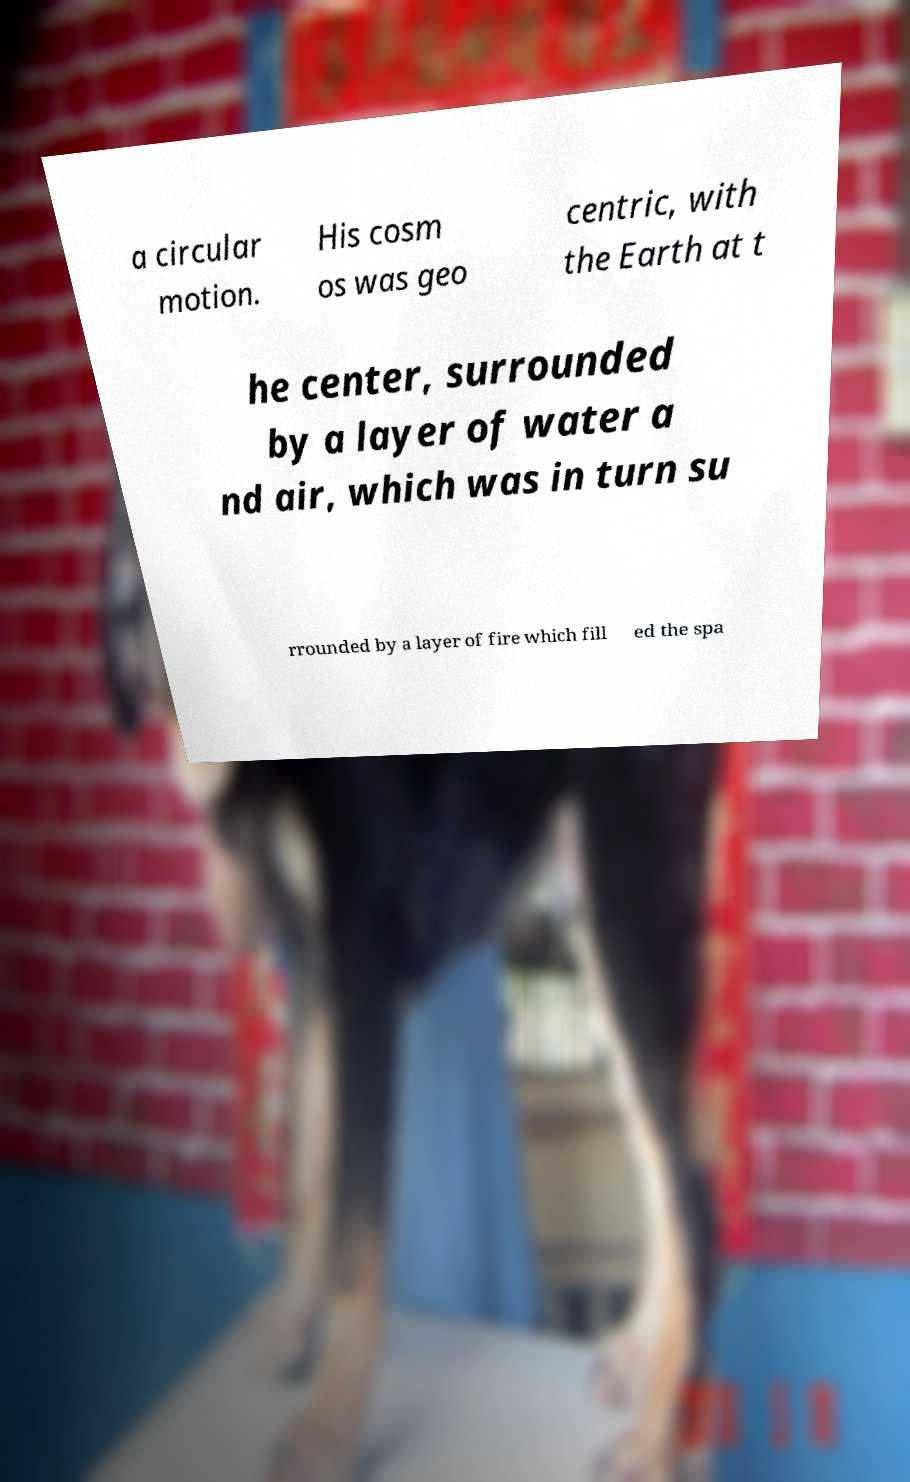There's text embedded in this image that I need extracted. Can you transcribe it verbatim? a circular motion. His cosm os was geo centric, with the Earth at t he center, surrounded by a layer of water a nd air, which was in turn su rrounded by a layer of fire which fill ed the spa 